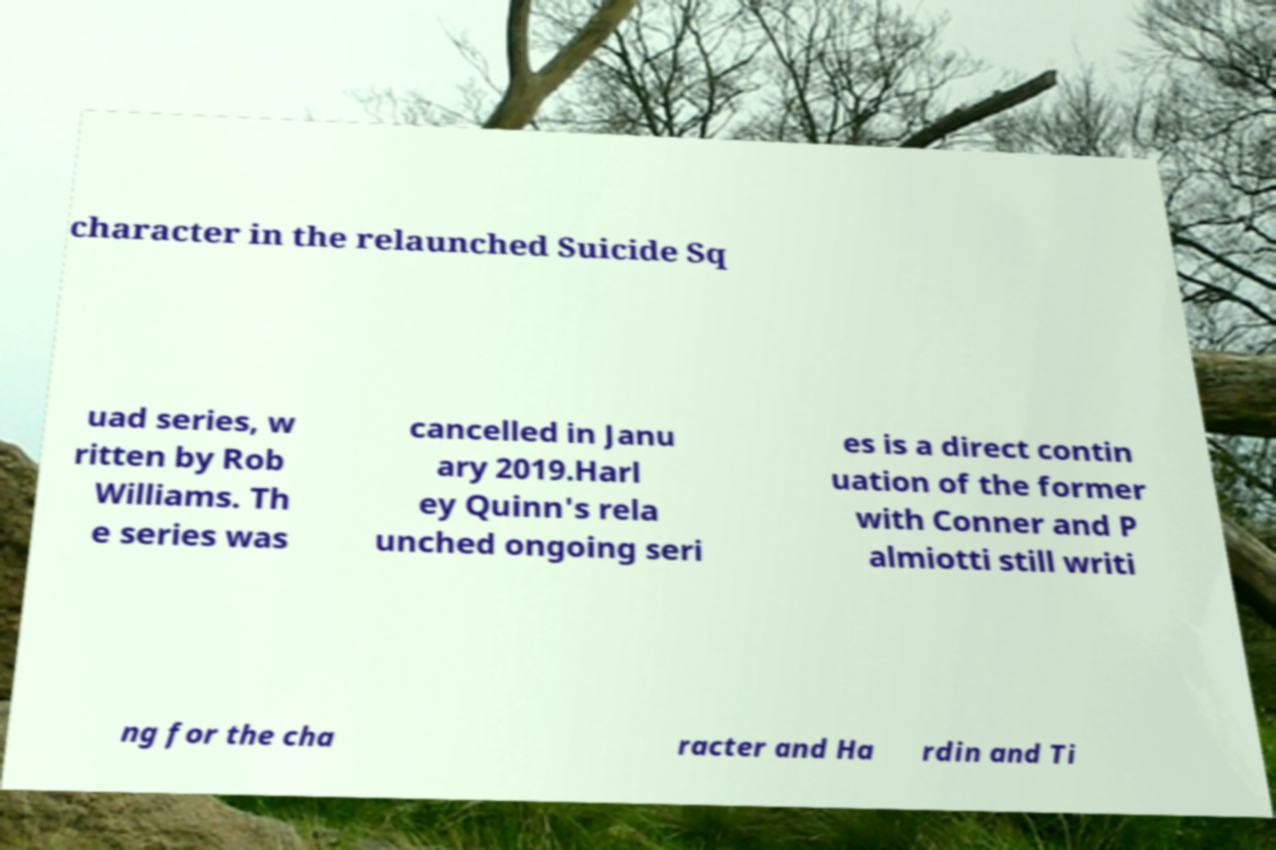Please identify and transcribe the text found in this image. character in the relaunched Suicide Sq uad series, w ritten by Rob Williams. Th e series was cancelled in Janu ary 2019.Harl ey Quinn's rela unched ongoing seri es is a direct contin uation of the former with Conner and P almiotti still writi ng for the cha racter and Ha rdin and Ti 